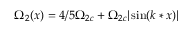Convert formula to latex. <formula><loc_0><loc_0><loc_500><loc_500>\Omega _ { 2 } ( x ) = 4 / 5 \Omega _ { 2 c } + \Omega _ { 2 c } | \sin ( k * x ) |</formula> 